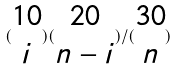Convert formula to latex. <formula><loc_0><loc_0><loc_500><loc_500>( \begin{matrix} 1 0 \\ i \end{matrix} ) ( \begin{matrix} 2 0 \\ n - i \end{matrix} ) / ( \begin{matrix} 3 0 \\ n \end{matrix} )</formula> 